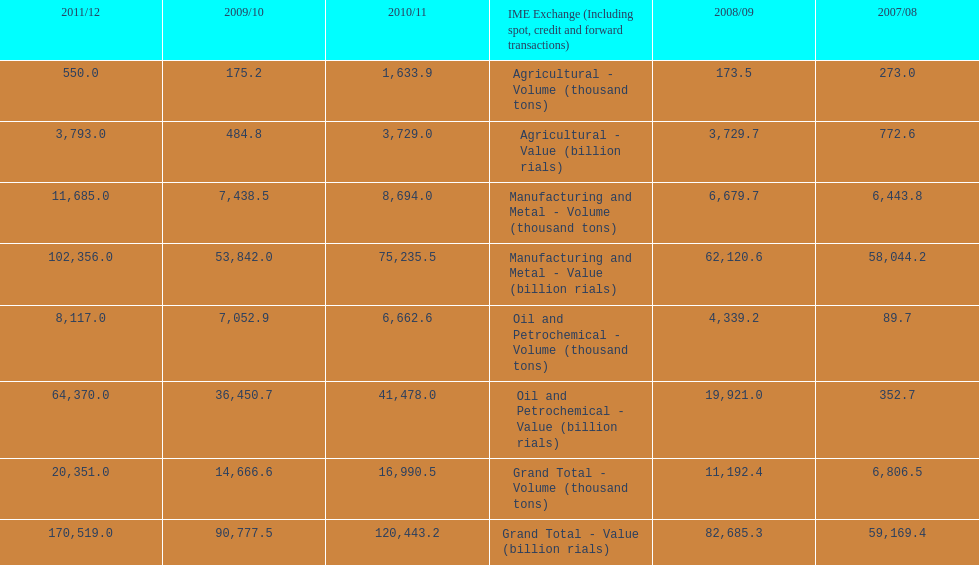What year saw the greatest value for manufacturing and metal in iran? 2011/12. 